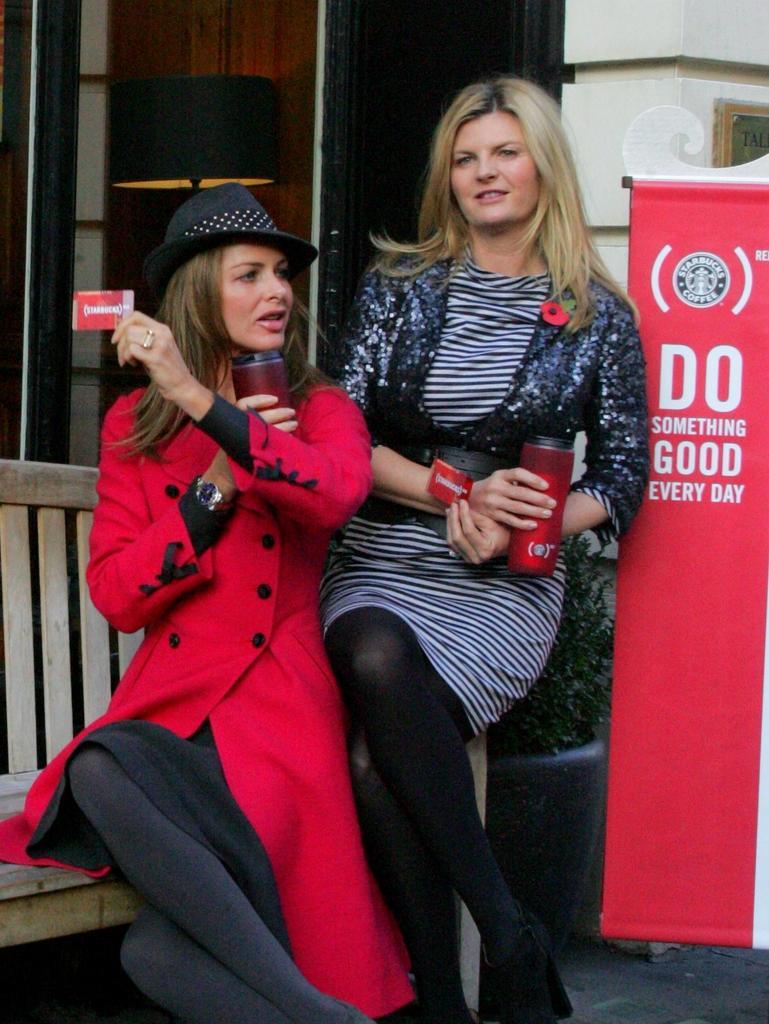Please provide a concise description of this image. Here in this picture we can see two women sitting on a bench over there and both of them are carrying bottles in their hands and the woman on the left side is wearing a red colored coat on her and also wearing a hat on her and both of them are holding some card in their hand and behind them we can see a banner present over there. 